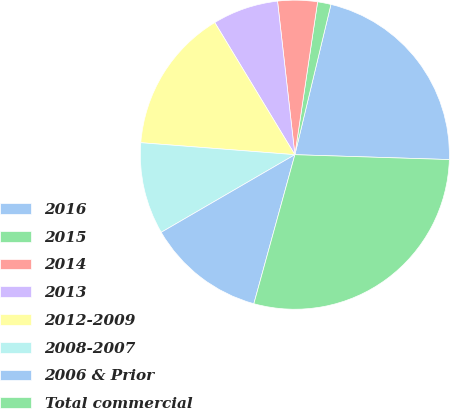Convert chart to OTSL. <chart><loc_0><loc_0><loc_500><loc_500><pie_chart><fcel>2016<fcel>2015<fcel>2014<fcel>2013<fcel>2012-2009<fcel>2008-2007<fcel>2006 & Prior<fcel>Total commercial<nl><fcel>21.75%<fcel>1.4%<fcel>4.14%<fcel>6.88%<fcel>15.09%<fcel>9.61%<fcel>12.35%<fcel>28.77%<nl></chart> 